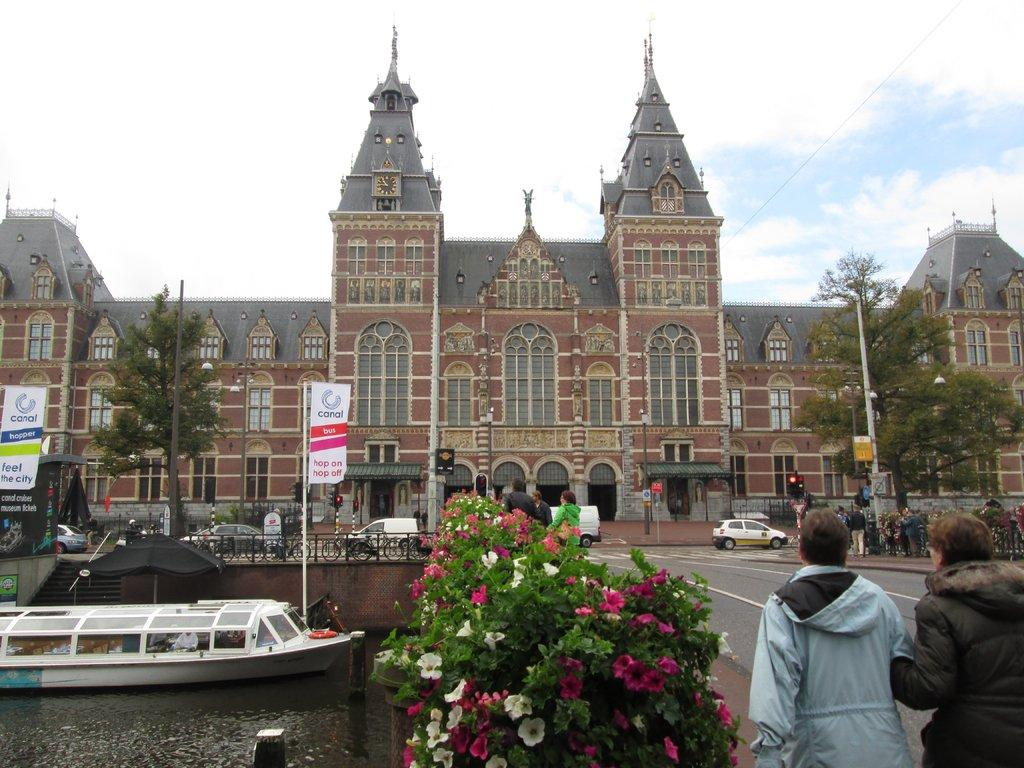What is in the river in the image? There is a boat in the river in the image. What are the people in the image doing? People are walking on the road in the image. What structure is located in front of the road? There is a building in front of the road in the image. What type of cloth is being used to cover the roots in the image? There is no cloth or roots present in the image. What color is the blood on the building in the image? There is no blood present in the image. 